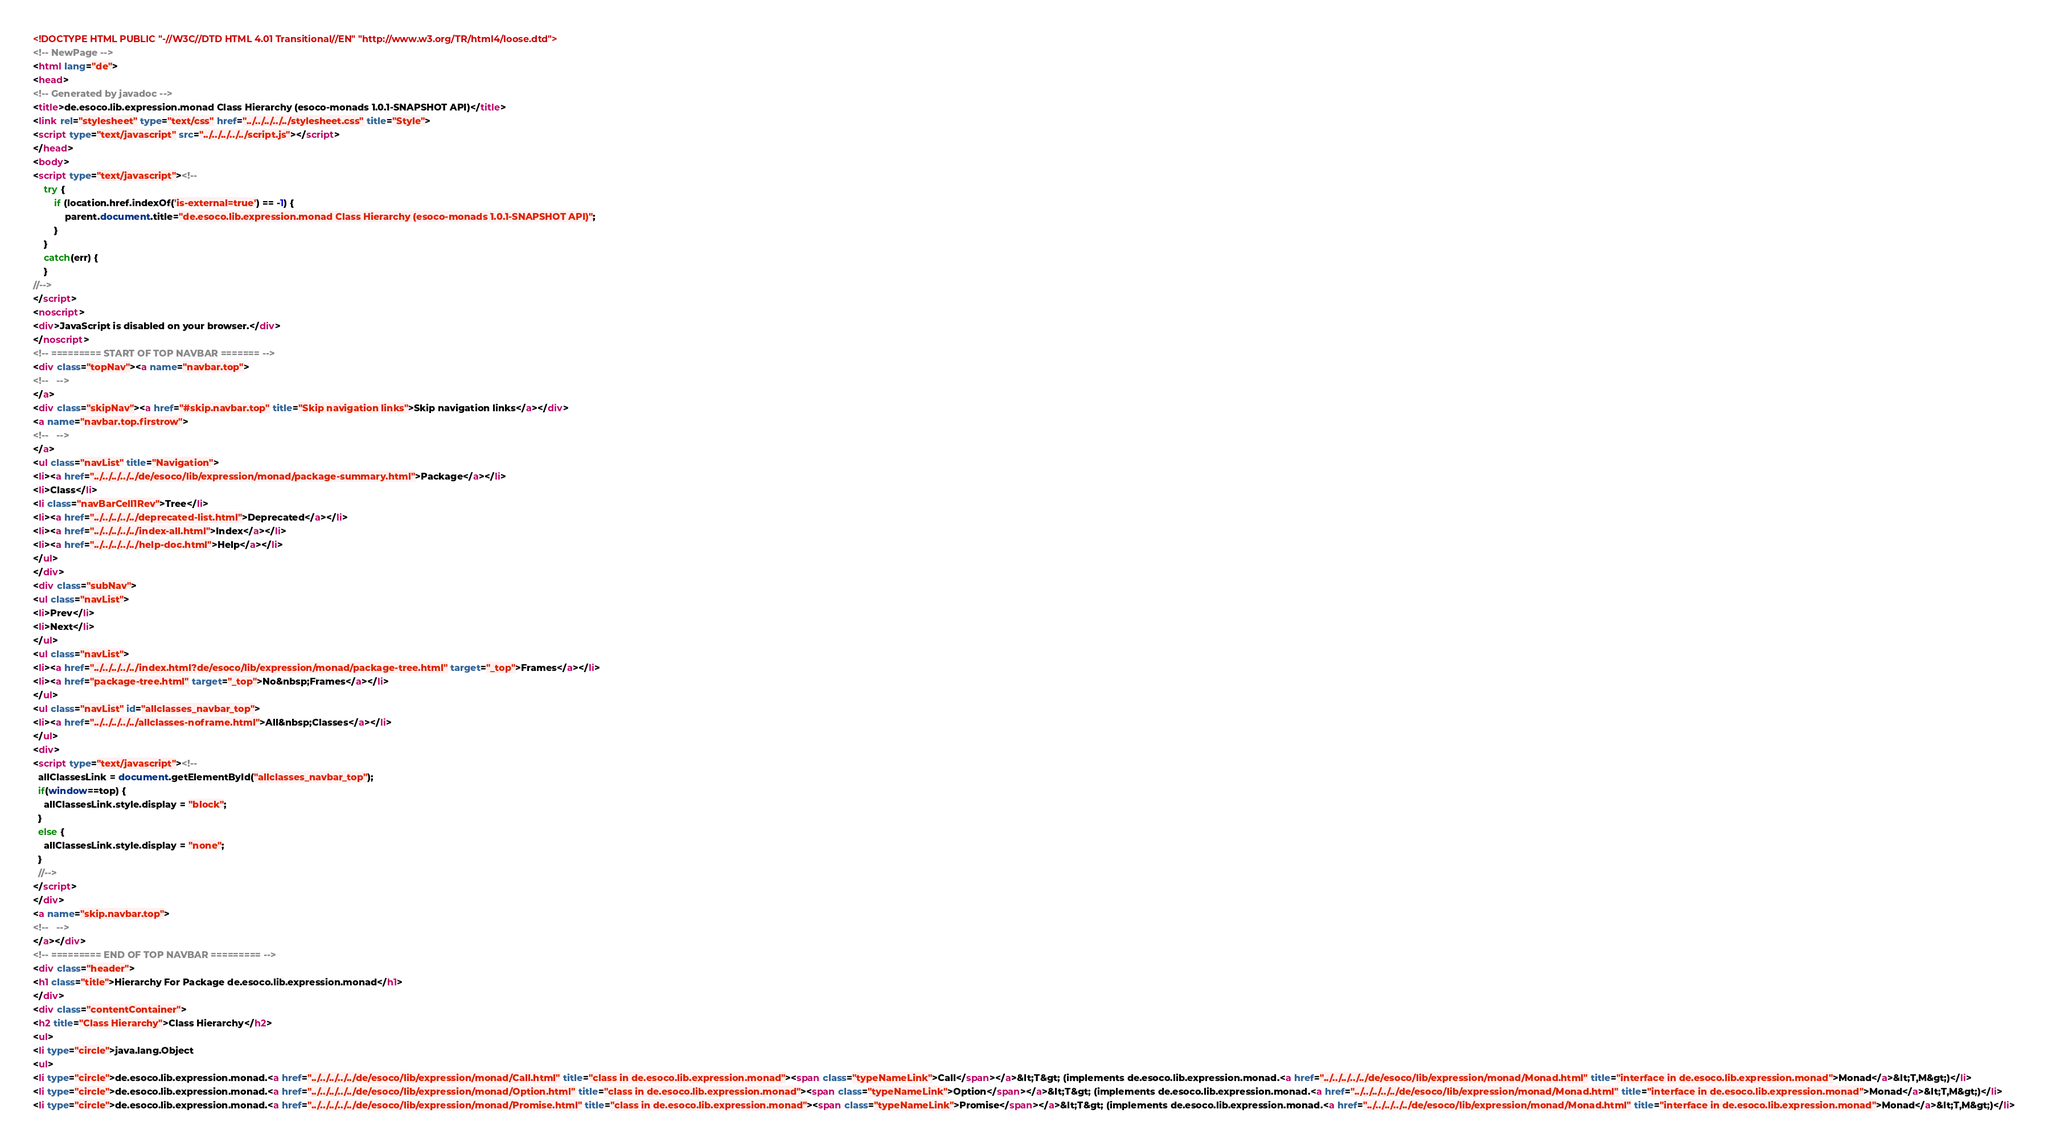Convert code to text. <code><loc_0><loc_0><loc_500><loc_500><_HTML_><!DOCTYPE HTML PUBLIC "-//W3C//DTD HTML 4.01 Transitional//EN" "http://www.w3.org/TR/html4/loose.dtd">
<!-- NewPage -->
<html lang="de">
<head>
<!-- Generated by javadoc -->
<title>de.esoco.lib.expression.monad Class Hierarchy (esoco-monads 1.0.1-SNAPSHOT API)</title>
<link rel="stylesheet" type="text/css" href="../../../../../stylesheet.css" title="Style">
<script type="text/javascript" src="../../../../../script.js"></script>
</head>
<body>
<script type="text/javascript"><!--
    try {
        if (location.href.indexOf('is-external=true') == -1) {
            parent.document.title="de.esoco.lib.expression.monad Class Hierarchy (esoco-monads 1.0.1-SNAPSHOT API)";
        }
    }
    catch(err) {
    }
//-->
</script>
<noscript>
<div>JavaScript is disabled on your browser.</div>
</noscript>
<!-- ========= START OF TOP NAVBAR ======= -->
<div class="topNav"><a name="navbar.top">
<!--   -->
</a>
<div class="skipNav"><a href="#skip.navbar.top" title="Skip navigation links">Skip navigation links</a></div>
<a name="navbar.top.firstrow">
<!--   -->
</a>
<ul class="navList" title="Navigation">
<li><a href="../../../../../de/esoco/lib/expression/monad/package-summary.html">Package</a></li>
<li>Class</li>
<li class="navBarCell1Rev">Tree</li>
<li><a href="../../../../../deprecated-list.html">Deprecated</a></li>
<li><a href="../../../../../index-all.html">Index</a></li>
<li><a href="../../../../../help-doc.html">Help</a></li>
</ul>
</div>
<div class="subNav">
<ul class="navList">
<li>Prev</li>
<li>Next</li>
</ul>
<ul class="navList">
<li><a href="../../../../../index.html?de/esoco/lib/expression/monad/package-tree.html" target="_top">Frames</a></li>
<li><a href="package-tree.html" target="_top">No&nbsp;Frames</a></li>
</ul>
<ul class="navList" id="allclasses_navbar_top">
<li><a href="../../../../../allclasses-noframe.html">All&nbsp;Classes</a></li>
</ul>
<div>
<script type="text/javascript"><!--
  allClassesLink = document.getElementById("allclasses_navbar_top");
  if(window==top) {
    allClassesLink.style.display = "block";
  }
  else {
    allClassesLink.style.display = "none";
  }
  //-->
</script>
</div>
<a name="skip.navbar.top">
<!--   -->
</a></div>
<!-- ========= END OF TOP NAVBAR ========= -->
<div class="header">
<h1 class="title">Hierarchy For Package de.esoco.lib.expression.monad</h1>
</div>
<div class="contentContainer">
<h2 title="Class Hierarchy">Class Hierarchy</h2>
<ul>
<li type="circle">java.lang.Object
<ul>
<li type="circle">de.esoco.lib.expression.monad.<a href="../../../../../de/esoco/lib/expression/monad/Call.html" title="class in de.esoco.lib.expression.monad"><span class="typeNameLink">Call</span></a>&lt;T&gt; (implements de.esoco.lib.expression.monad.<a href="../../../../../de/esoco/lib/expression/monad/Monad.html" title="interface in de.esoco.lib.expression.monad">Monad</a>&lt;T,M&gt;)</li>
<li type="circle">de.esoco.lib.expression.monad.<a href="../../../../../de/esoco/lib/expression/monad/Option.html" title="class in de.esoco.lib.expression.monad"><span class="typeNameLink">Option</span></a>&lt;T&gt; (implements de.esoco.lib.expression.monad.<a href="../../../../../de/esoco/lib/expression/monad/Monad.html" title="interface in de.esoco.lib.expression.monad">Monad</a>&lt;T,M&gt;)</li>
<li type="circle">de.esoco.lib.expression.monad.<a href="../../../../../de/esoco/lib/expression/monad/Promise.html" title="class in de.esoco.lib.expression.monad"><span class="typeNameLink">Promise</span></a>&lt;T&gt; (implements de.esoco.lib.expression.monad.<a href="../../../../../de/esoco/lib/expression/monad/Monad.html" title="interface in de.esoco.lib.expression.monad">Monad</a>&lt;T,M&gt;)</li></code> 